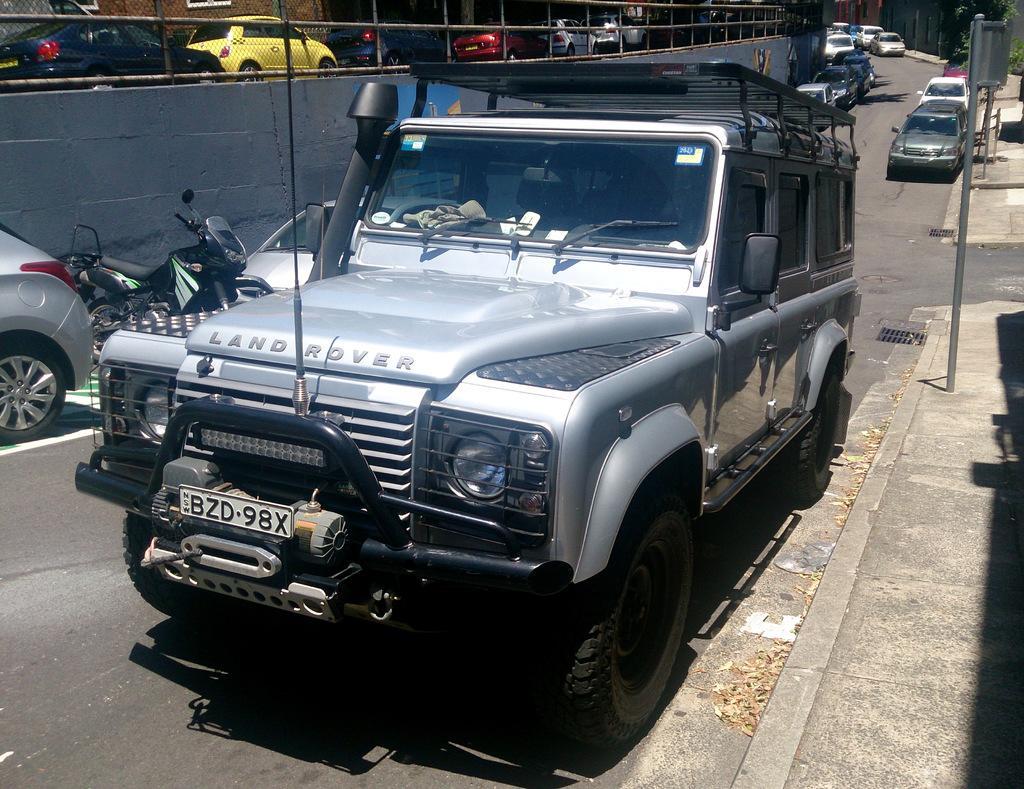In one or two sentences, can you explain what this image depicts? In this image we can see a group of vehicles on a surface. On the right side, we can see a pole on the surface. Behind the vehicles we can see a wall and a fencing. At the top we can see a group of vehicles. In the top right corner we can see trees and a fencing. 